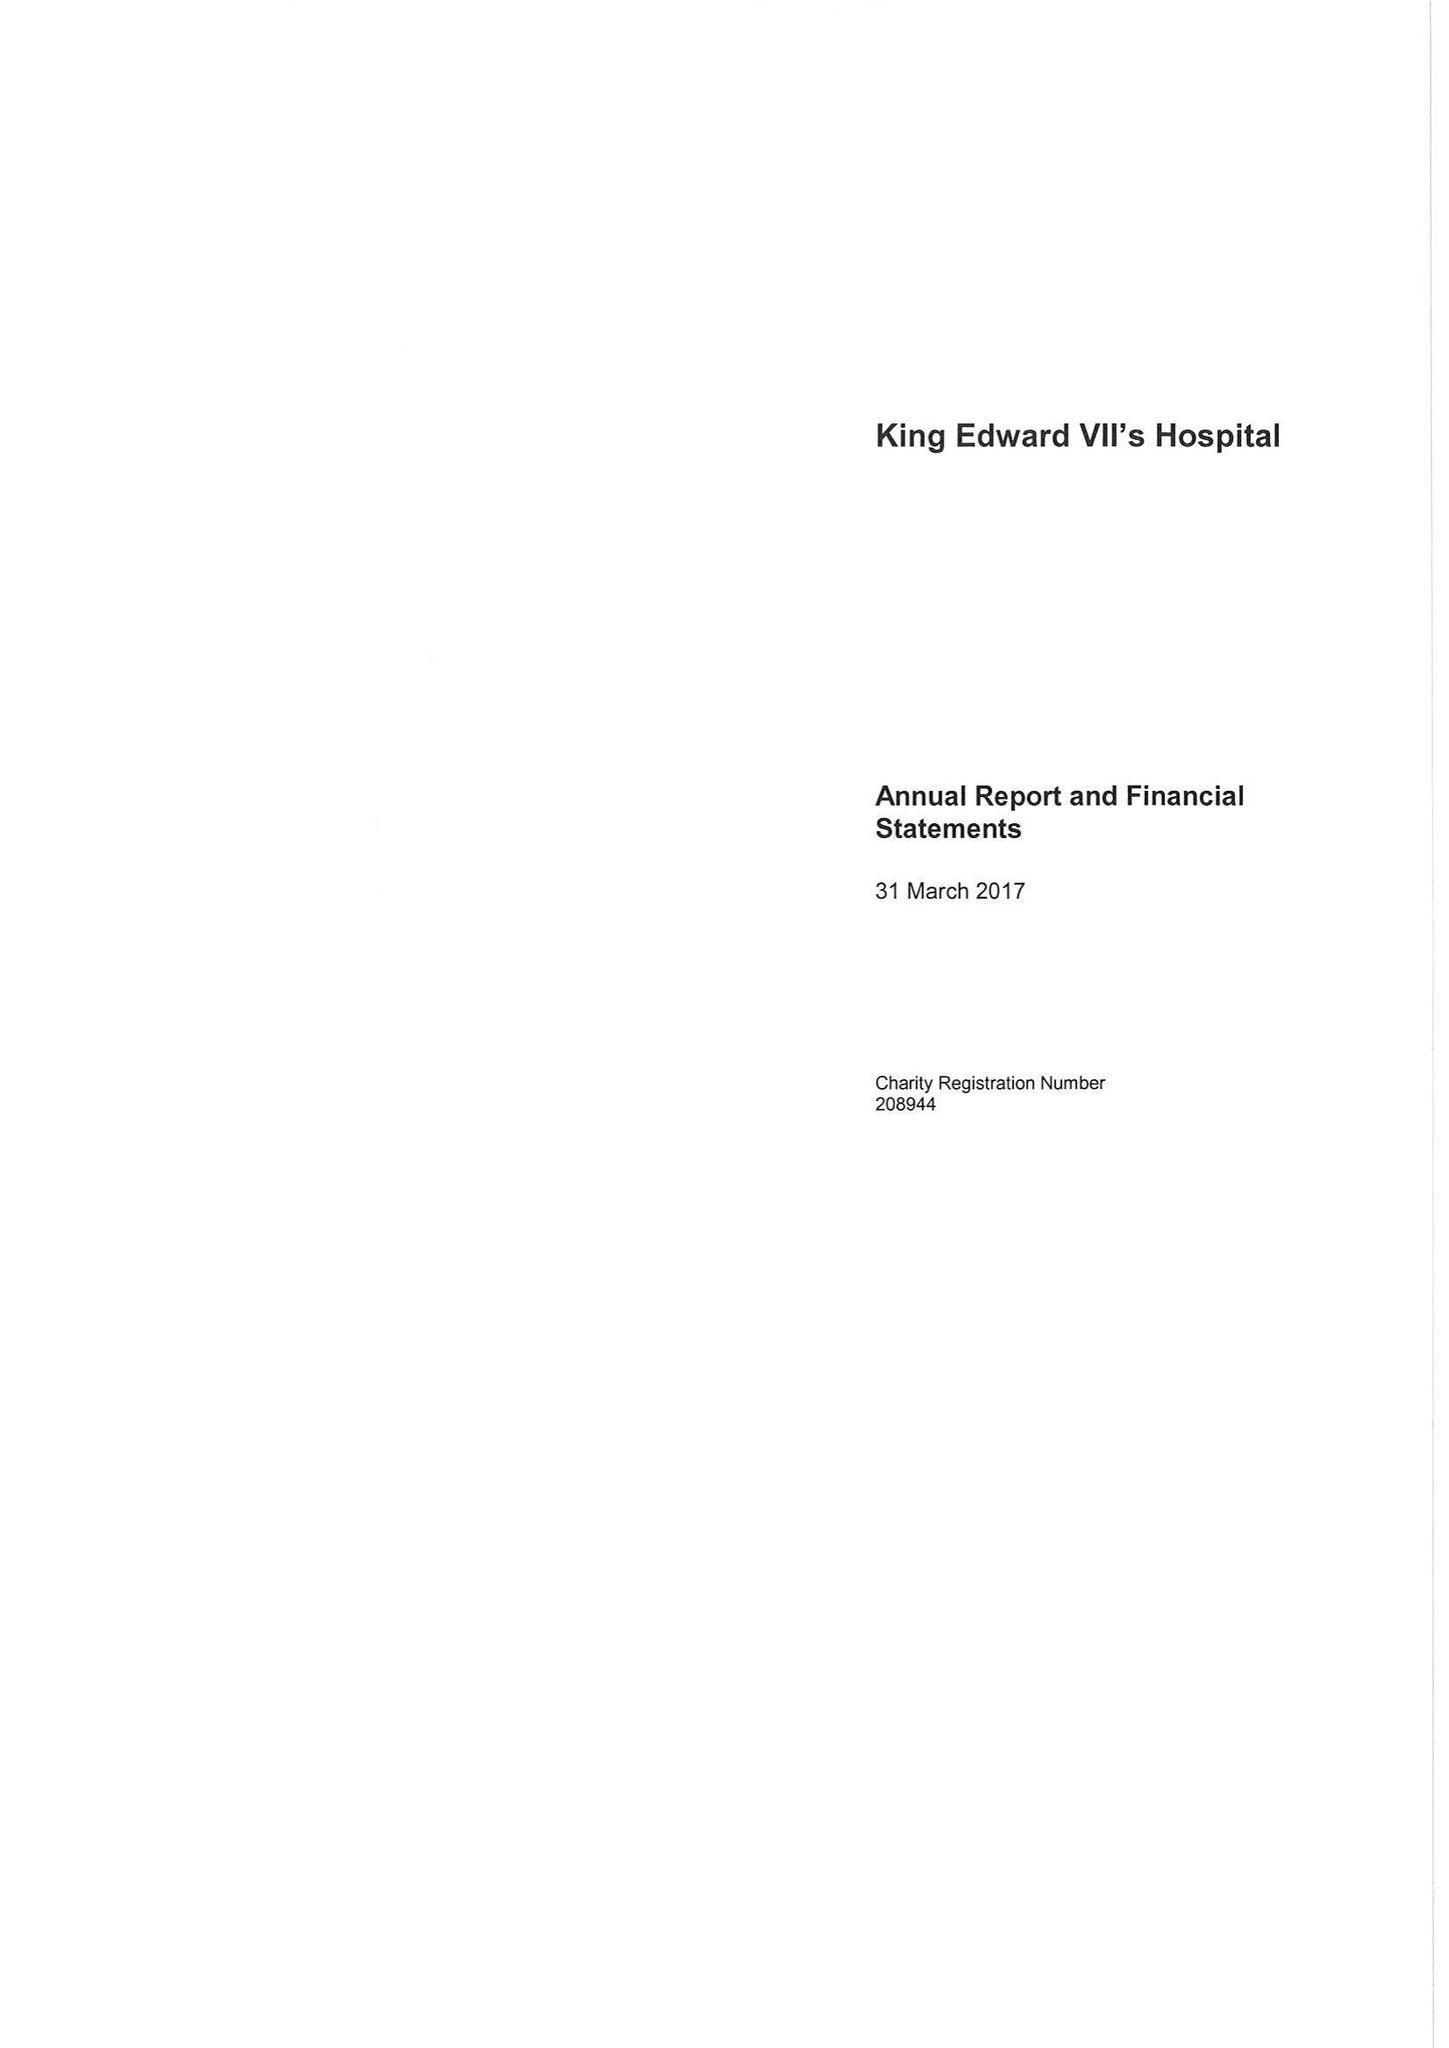What is the value for the address__street_line?
Answer the question using a single word or phrase. BEAUMONT STREET 